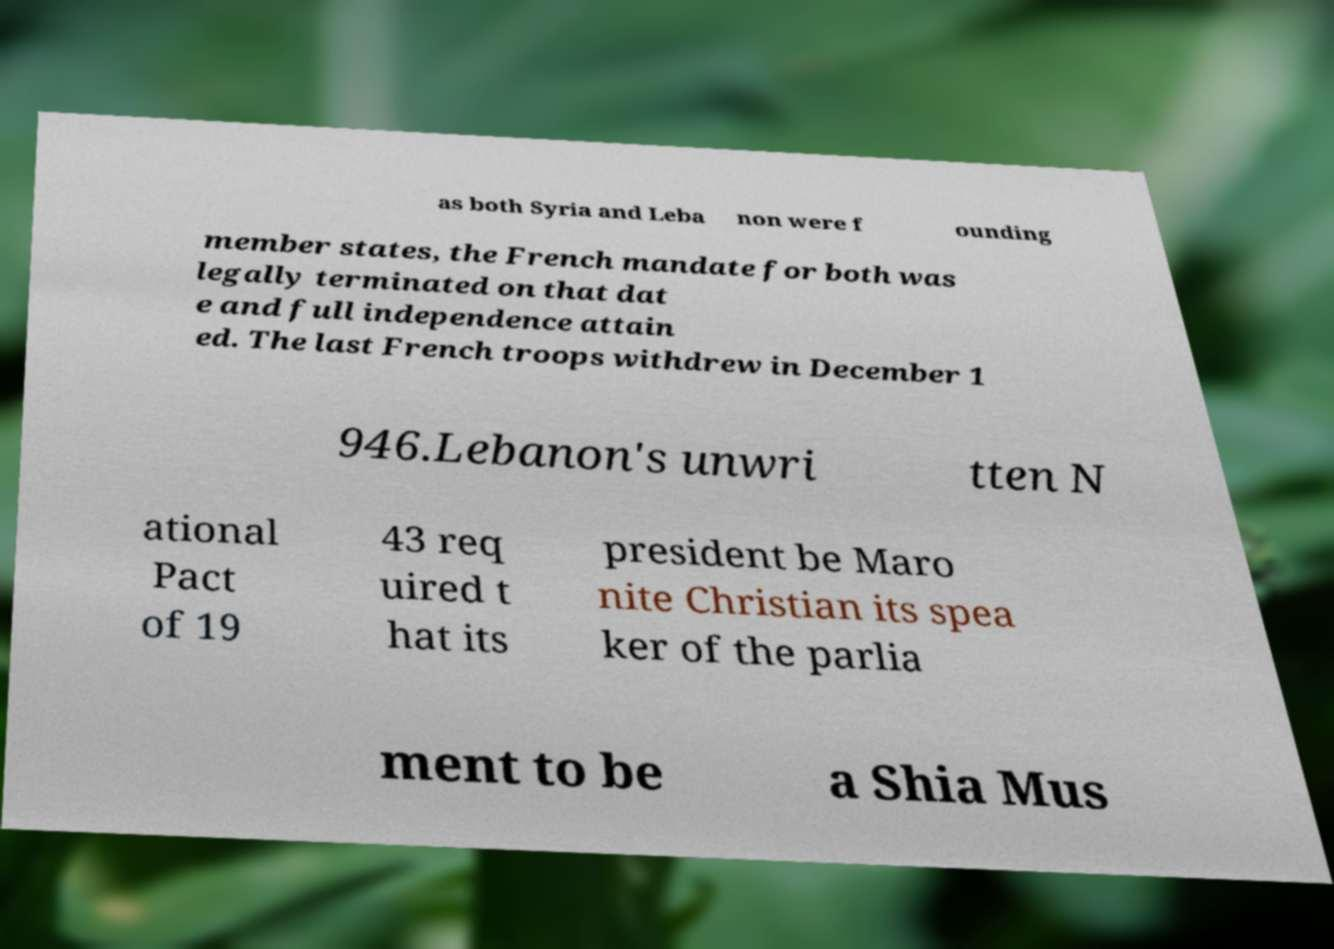Can you accurately transcribe the text from the provided image for me? as both Syria and Leba non were f ounding member states, the French mandate for both was legally terminated on that dat e and full independence attain ed. The last French troops withdrew in December 1 946.Lebanon's unwri tten N ational Pact of 19 43 req uired t hat its president be Maro nite Christian its spea ker of the parlia ment to be a Shia Mus 